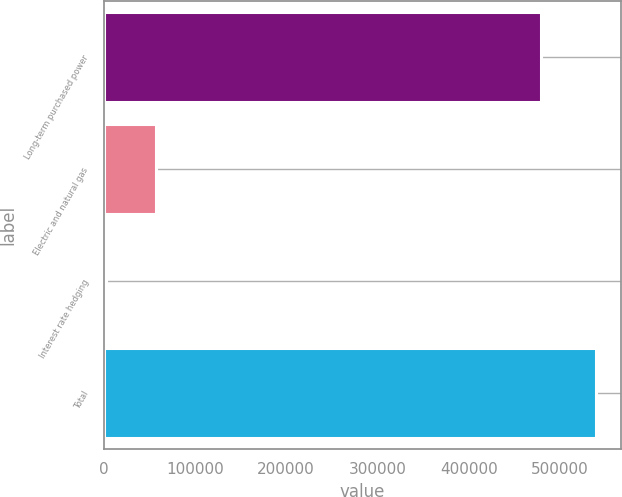<chart> <loc_0><loc_0><loc_500><loc_500><bar_chart><fcel>Long-term purchased power<fcel>Electric and natural gas<fcel>Interest rate hedging<fcel>Total<nl><fcel>478853<fcel>57797<fcel>2432<fcel>539082<nl></chart> 